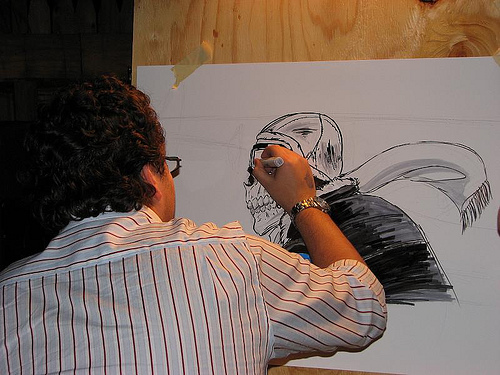<image>
Is the artist behind the drawing? No. The artist is not behind the drawing. From this viewpoint, the artist appears to be positioned elsewhere in the scene. 